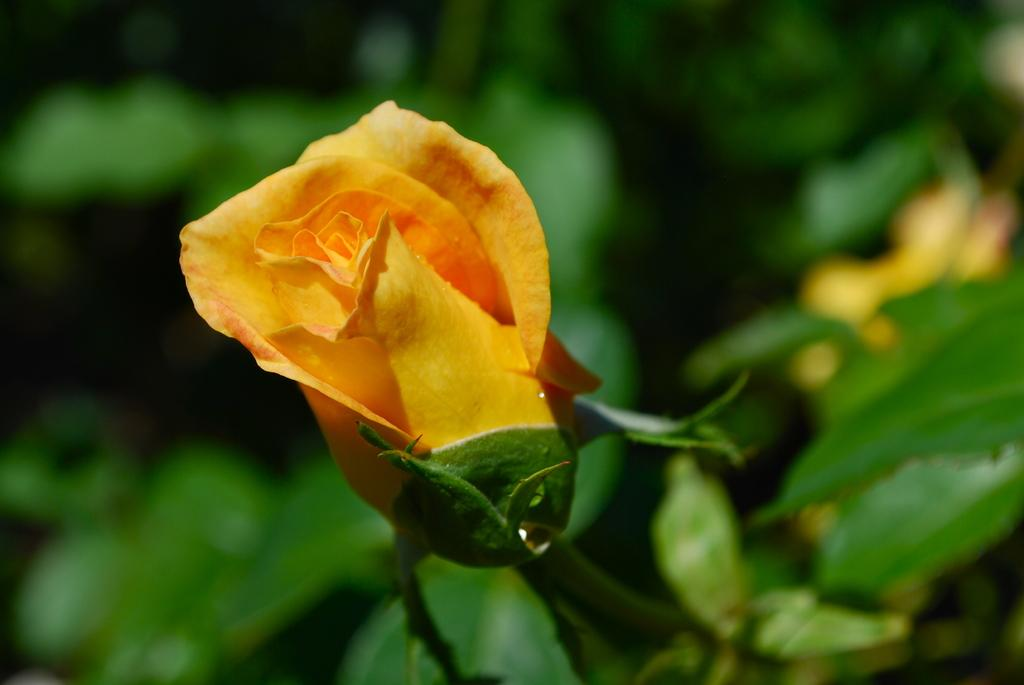What type of flower is in the picture? There is a yellow rose in the picture. What else can be seen on the right side of the picture? There are leaves on the right side of the picture. How would you describe the background of the image? The backdrop of the image is blurred. Can you see a robin perched on the cactus in the picture? There is no robin or cactus present in the picture; it features a yellow rose and leaves. 